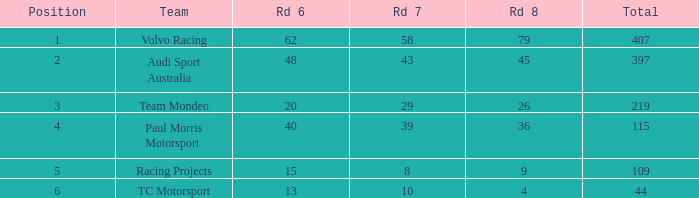What is the sum of values of Rd 7 with RD 6 less than 48 and Rd 8 less than 4 for TC Motorsport in a position greater than 1? None. 